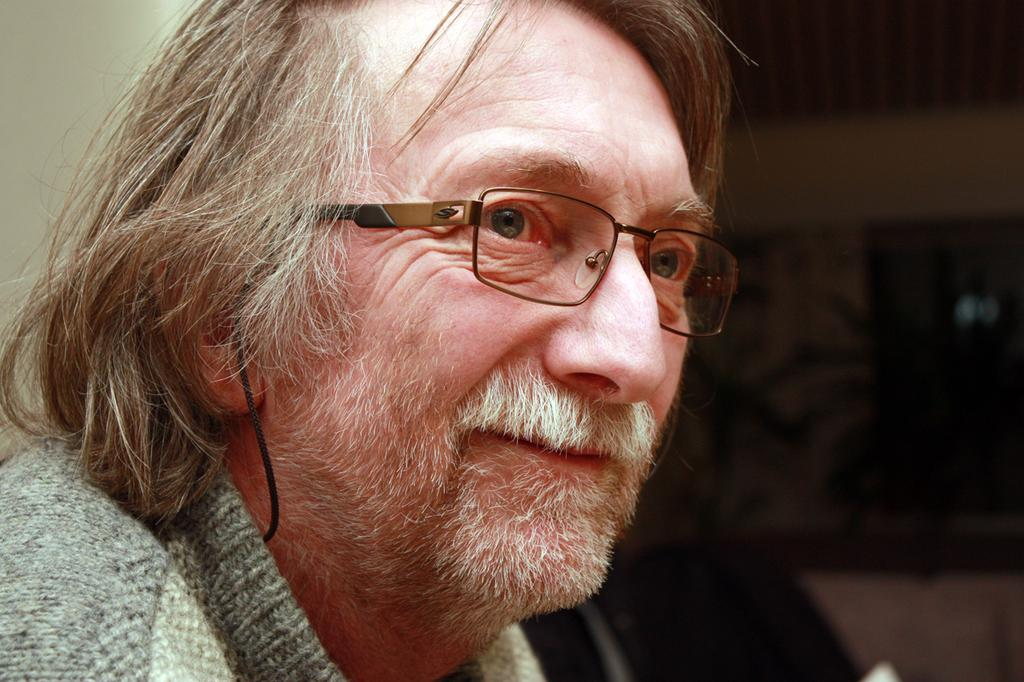Who is present in the image? There is a man in the image. What is the man wearing? The man is wearing spectacles. Where is the man located in relation to the wall? The man is near a wall. What can be seen near the wall? There are objects near the wall. How would you describe the background of the image? The background of the image is blurred. What type of corn is being served for the meal in the image? There is no corn or meal present in the image; it features a man wearing spectacles near a wall with objects nearby. Can you tell me how many hens are visible in the image? There are no hens present in the image. 